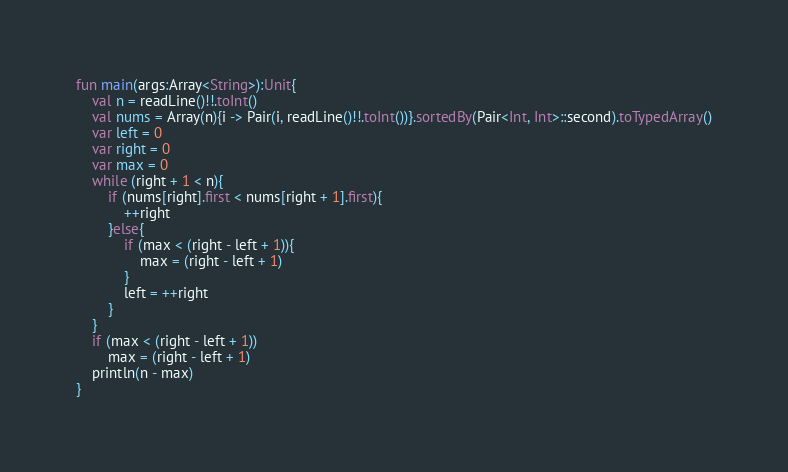<code> <loc_0><loc_0><loc_500><loc_500><_Kotlin_>fun main(args:Array<String>):Unit{
    val n = readLine()!!.toInt()
    val nums = Array(n){i -> Pair(i, readLine()!!.toInt())}.sortedBy(Pair<Int, Int>::second).toTypedArray()
    var left = 0
    var right = 0
    var max = 0
    while (right + 1 < n){
        if (nums[right].first < nums[right + 1].first){
            ++right
        }else{
            if (max < (right - left + 1)){
                max = (right - left + 1)
            }
            left = ++right
        }
    }
    if (max < (right - left + 1))
        max = (right - left + 1)
    println(n - max)
}</code> 